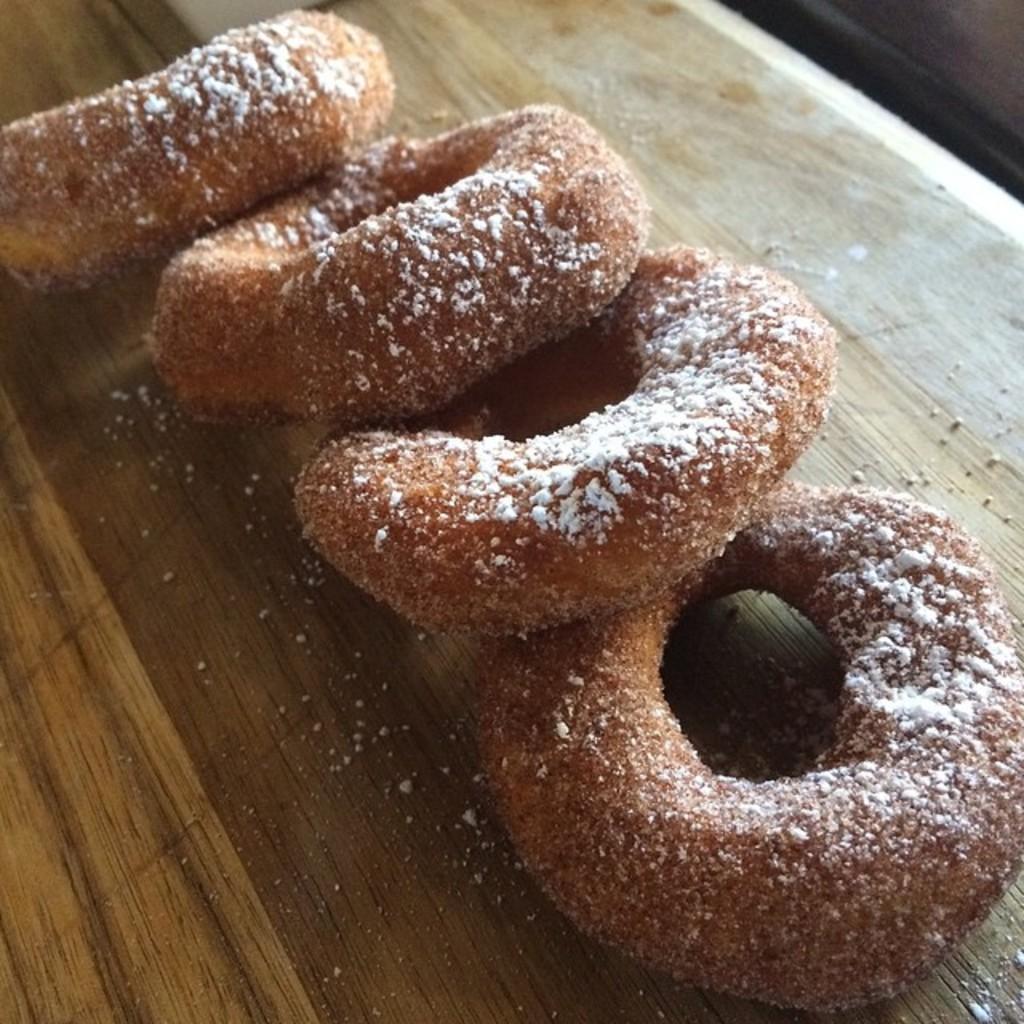Please provide a concise description of this image. In the image there are donuts with flour above it on a wooden table. 